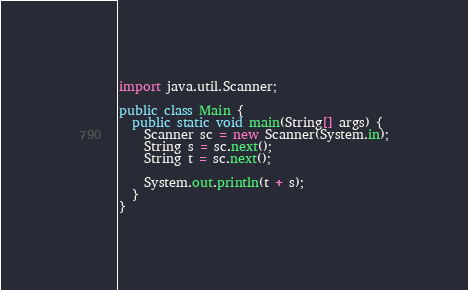<code> <loc_0><loc_0><loc_500><loc_500><_Java_>import java.util.Scanner;

public class Main {
  public static void main(String[] args) {
    Scanner sc = new Scanner(System.in);
    String s = sc.next();
    String t = sc.next();

    System.out.println(t + s);
  }
}
</code> 